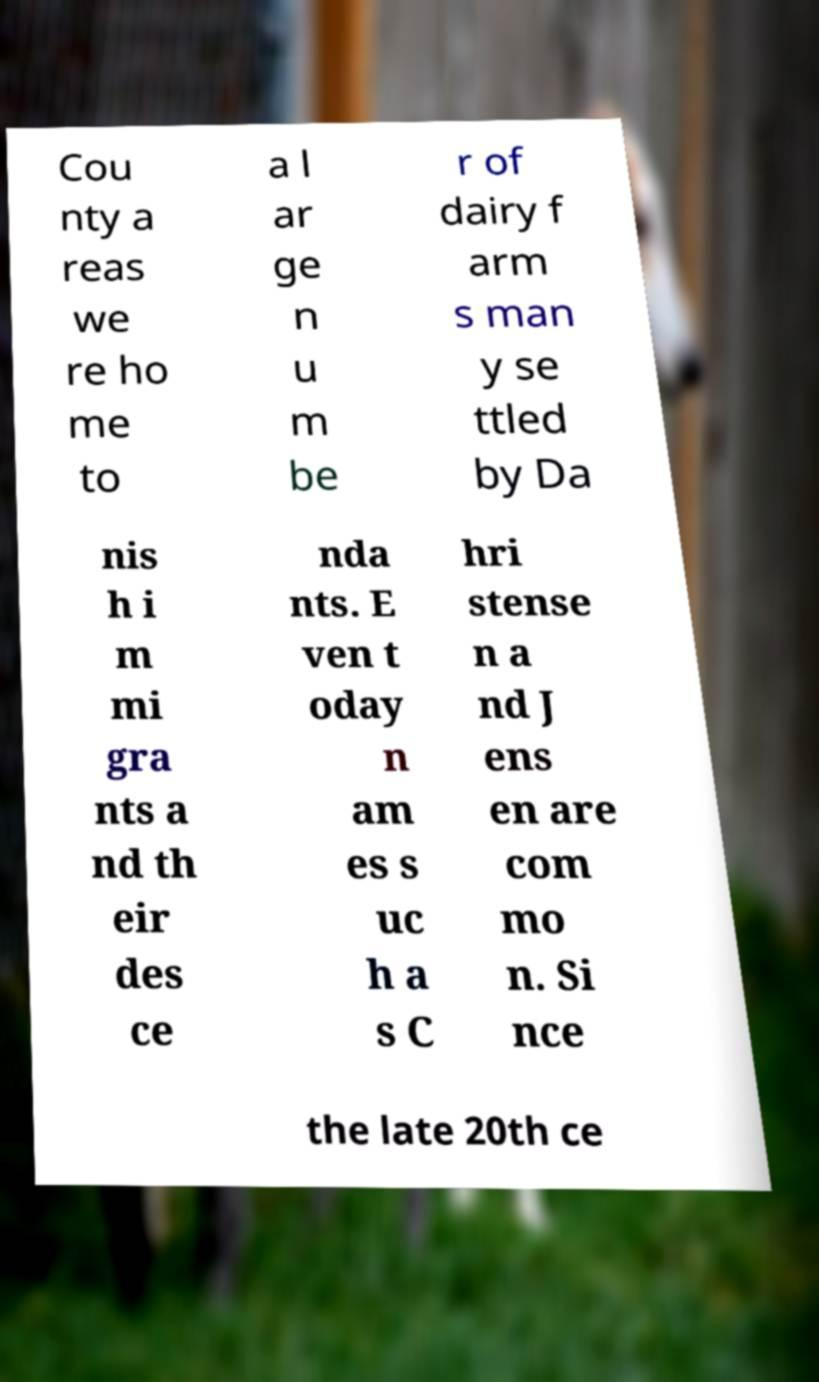For documentation purposes, I need the text within this image transcribed. Could you provide that? Cou nty a reas we re ho me to a l ar ge n u m be r of dairy f arm s man y se ttled by Da nis h i m mi gra nts a nd th eir des ce nda nts. E ven t oday n am es s uc h a s C hri stense n a nd J ens en are com mo n. Si nce the late 20th ce 